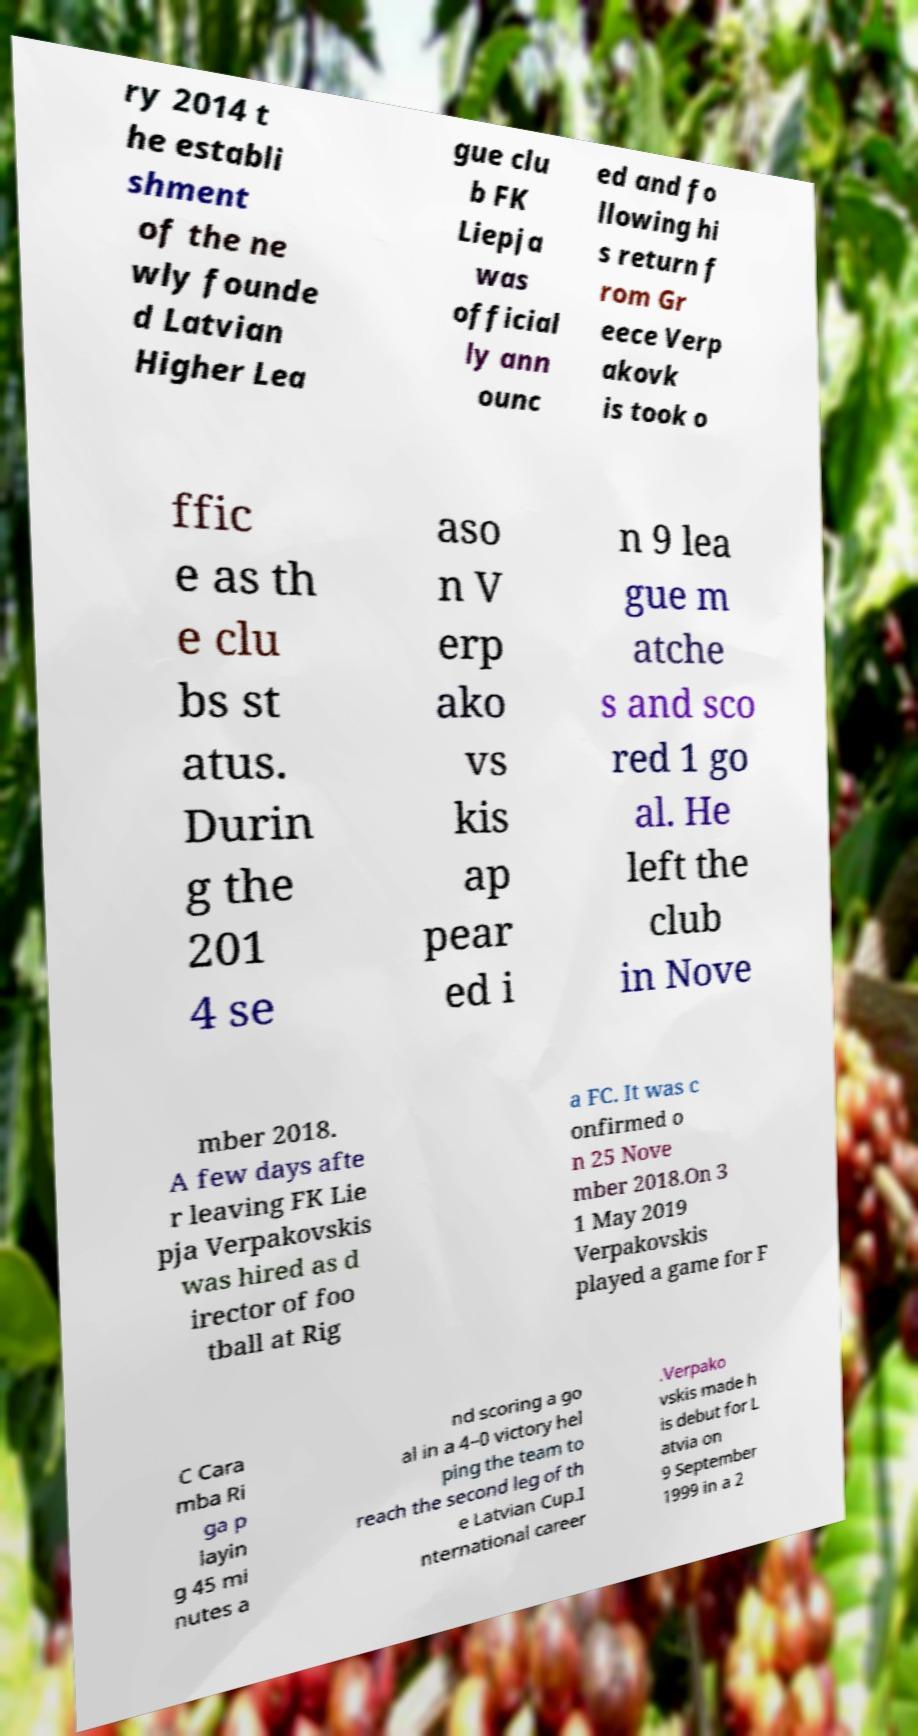Can you accurately transcribe the text from the provided image for me? ry 2014 t he establi shment of the ne wly founde d Latvian Higher Lea gue clu b FK Liepja was official ly ann ounc ed and fo llowing hi s return f rom Gr eece Verp akovk is took o ffic e as th e clu bs st atus. Durin g the 201 4 se aso n V erp ako vs kis ap pear ed i n 9 lea gue m atche s and sco red 1 go al. He left the club in Nove mber 2018. A few days afte r leaving FK Lie pja Verpakovskis was hired as d irector of foo tball at Rig a FC. It was c onfirmed o n 25 Nove mber 2018.On 3 1 May 2019 Verpakovskis played a game for F C Cara mba Ri ga p layin g 45 mi nutes a nd scoring a go al in a 4–0 victory hel ping the team to reach the second leg of th e Latvian Cup.I nternational career .Verpako vskis made h is debut for L atvia on 9 September 1999 in a 2 